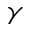Convert formula to latex. <formula><loc_0><loc_0><loc_500><loc_500>\gamma</formula> 